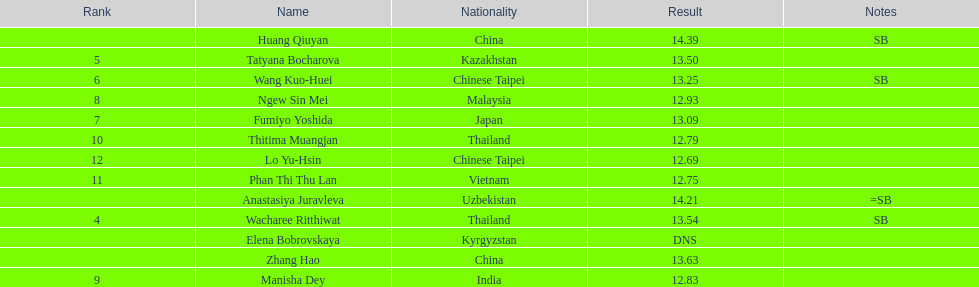How many athletes were from china? 2. Help me parse the entirety of this table. {'header': ['Rank', 'Name', 'Nationality', 'Result', 'Notes'], 'rows': [['', 'Huang Qiuyan', 'China', '14.39', 'SB'], ['5', 'Tatyana Bocharova', 'Kazakhstan', '13.50', ''], ['6', 'Wang Kuo-Huei', 'Chinese Taipei', '13.25', 'SB'], ['8', 'Ngew Sin Mei', 'Malaysia', '12.93', ''], ['7', 'Fumiyo Yoshida', 'Japan', '13.09', ''], ['10', 'Thitima Muangjan', 'Thailand', '12.79', ''], ['12', 'Lo Yu-Hsin', 'Chinese Taipei', '12.69', ''], ['11', 'Phan Thi Thu Lan', 'Vietnam', '12.75', ''], ['', 'Anastasiya Juravleva', 'Uzbekistan', '14.21', '=SB'], ['4', 'Wacharee Ritthiwat', 'Thailand', '13.54', 'SB'], ['', 'Elena Bobrovskaya', 'Kyrgyzstan', 'DNS', ''], ['', 'Zhang Hao', 'China', '13.63', ''], ['9', 'Manisha Dey', 'India', '12.83', '']]} 